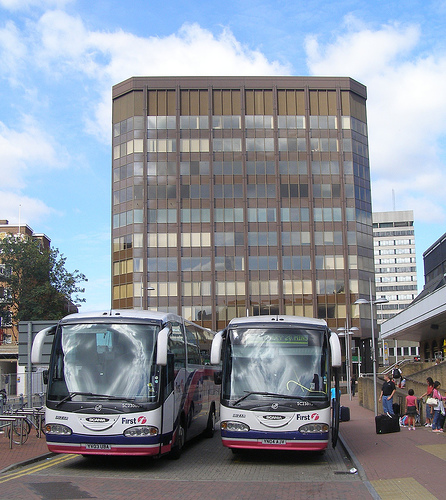Can you tell me what the signs on the bus indicate? The bus signs are slightly blurred but look like route numbers or directions for passengers indicating the service routes or stops. 